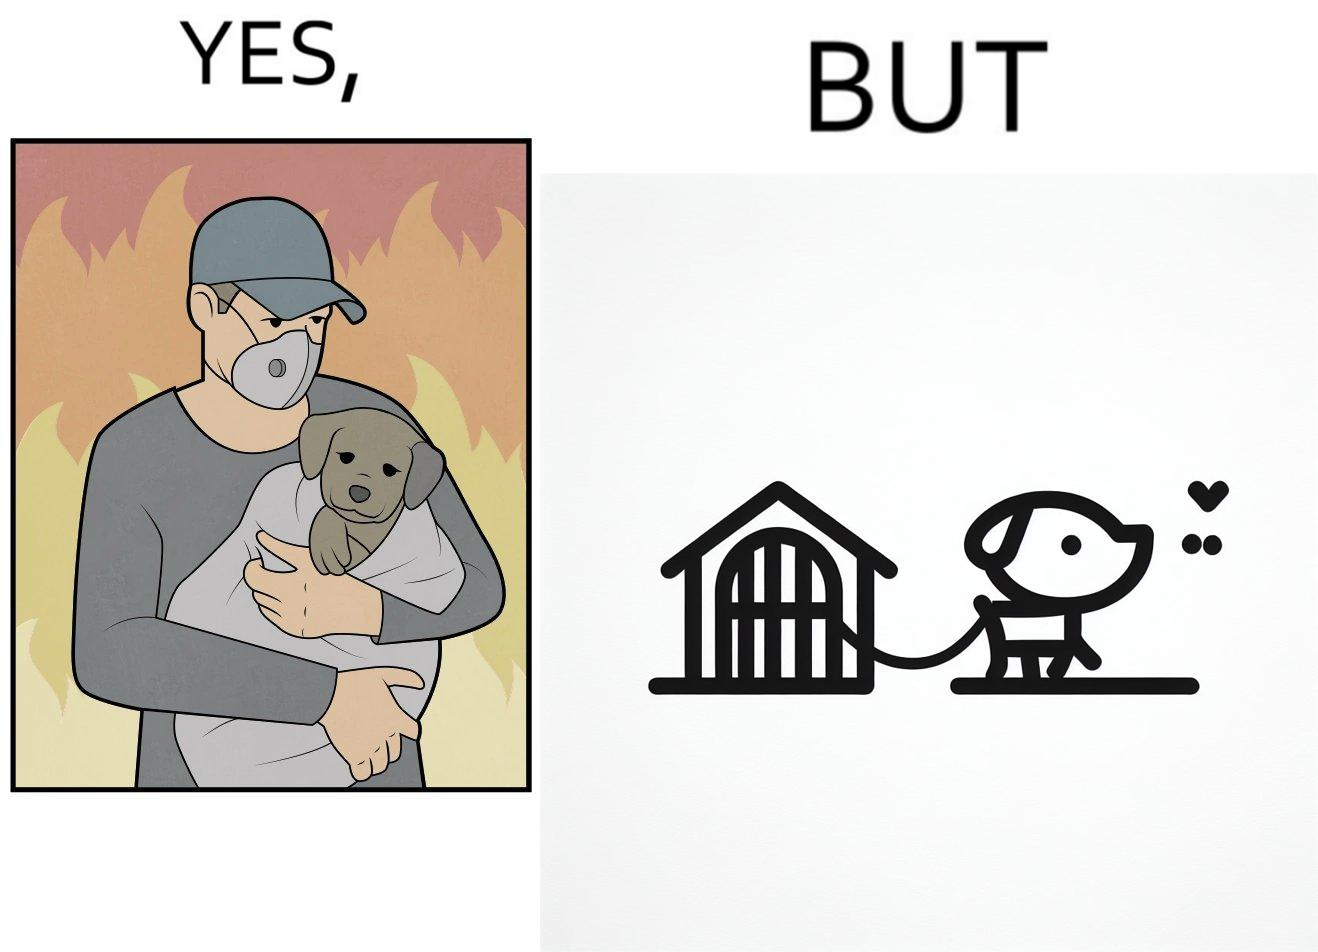Describe the contrast between the left and right parts of this image. In the left part of the image: a man, wearing mask, protecting a puppy from fire, in the background, by covering it in a sheet of cloth In the right part of the image: a puppy chained to a kennel 